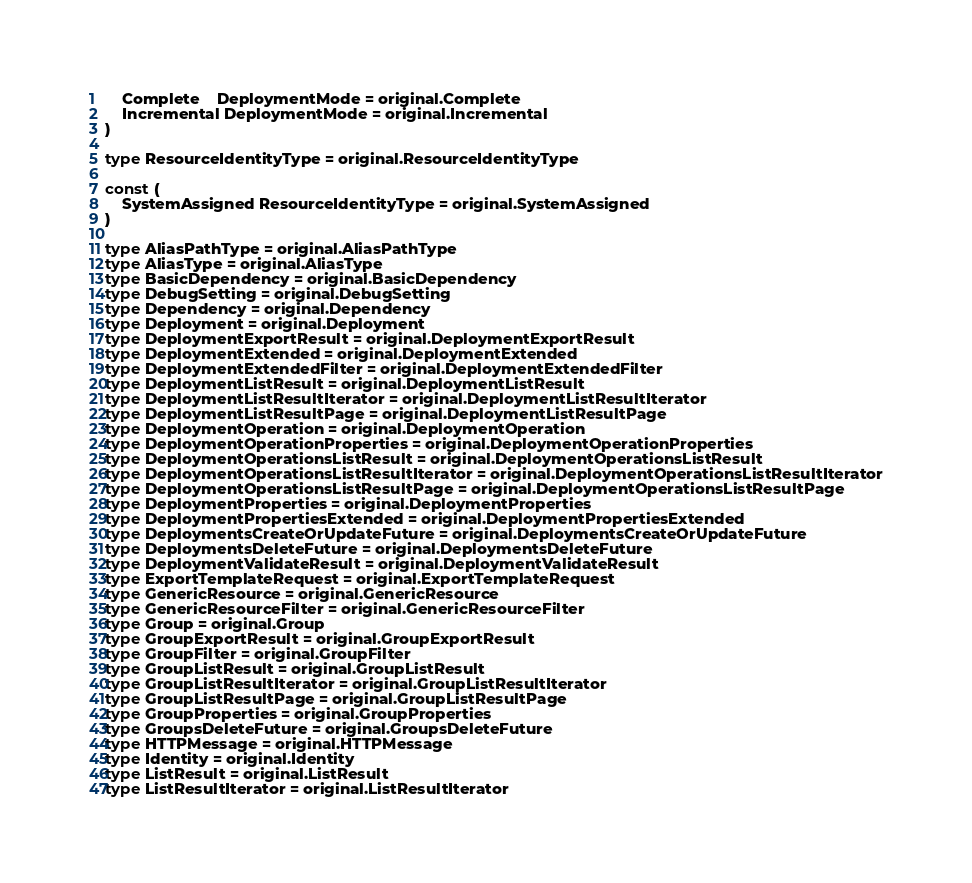Convert code to text. <code><loc_0><loc_0><loc_500><loc_500><_Go_>	Complete    DeploymentMode = original.Complete
	Incremental DeploymentMode = original.Incremental
)

type ResourceIdentityType = original.ResourceIdentityType

const (
	SystemAssigned ResourceIdentityType = original.SystemAssigned
)

type AliasPathType = original.AliasPathType
type AliasType = original.AliasType
type BasicDependency = original.BasicDependency
type DebugSetting = original.DebugSetting
type Dependency = original.Dependency
type Deployment = original.Deployment
type DeploymentExportResult = original.DeploymentExportResult
type DeploymentExtended = original.DeploymentExtended
type DeploymentExtendedFilter = original.DeploymentExtendedFilter
type DeploymentListResult = original.DeploymentListResult
type DeploymentListResultIterator = original.DeploymentListResultIterator
type DeploymentListResultPage = original.DeploymentListResultPage
type DeploymentOperation = original.DeploymentOperation
type DeploymentOperationProperties = original.DeploymentOperationProperties
type DeploymentOperationsListResult = original.DeploymentOperationsListResult
type DeploymentOperationsListResultIterator = original.DeploymentOperationsListResultIterator
type DeploymentOperationsListResultPage = original.DeploymentOperationsListResultPage
type DeploymentProperties = original.DeploymentProperties
type DeploymentPropertiesExtended = original.DeploymentPropertiesExtended
type DeploymentsCreateOrUpdateFuture = original.DeploymentsCreateOrUpdateFuture
type DeploymentsDeleteFuture = original.DeploymentsDeleteFuture
type DeploymentValidateResult = original.DeploymentValidateResult
type ExportTemplateRequest = original.ExportTemplateRequest
type GenericResource = original.GenericResource
type GenericResourceFilter = original.GenericResourceFilter
type Group = original.Group
type GroupExportResult = original.GroupExportResult
type GroupFilter = original.GroupFilter
type GroupListResult = original.GroupListResult
type GroupListResultIterator = original.GroupListResultIterator
type GroupListResultPage = original.GroupListResultPage
type GroupProperties = original.GroupProperties
type GroupsDeleteFuture = original.GroupsDeleteFuture
type HTTPMessage = original.HTTPMessage
type Identity = original.Identity
type ListResult = original.ListResult
type ListResultIterator = original.ListResultIterator</code> 